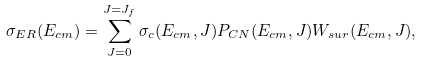Convert formula to latex. <formula><loc_0><loc_0><loc_500><loc_500>\sigma _ { E R } ( E _ { c m } ) = \sum _ { J = 0 } ^ { J = J _ { f } } \sigma _ { c } ( E _ { c m } , J ) P _ { C N } ( E _ { c m } , J ) W _ { s u r } ( E _ { c m } , J ) ,</formula> 